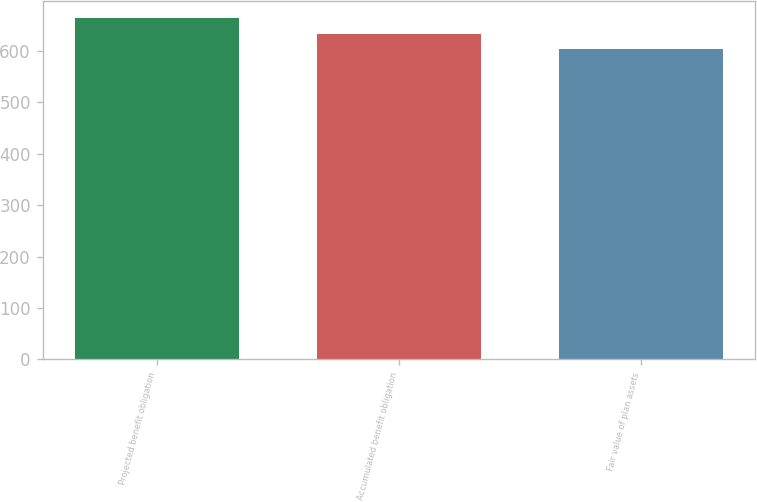<chart> <loc_0><loc_0><loc_500><loc_500><bar_chart><fcel>Projected benefit obligation<fcel>Accumulated benefit obligation<fcel>Fair value of plan assets<nl><fcel>665<fcel>633<fcel>604<nl></chart> 